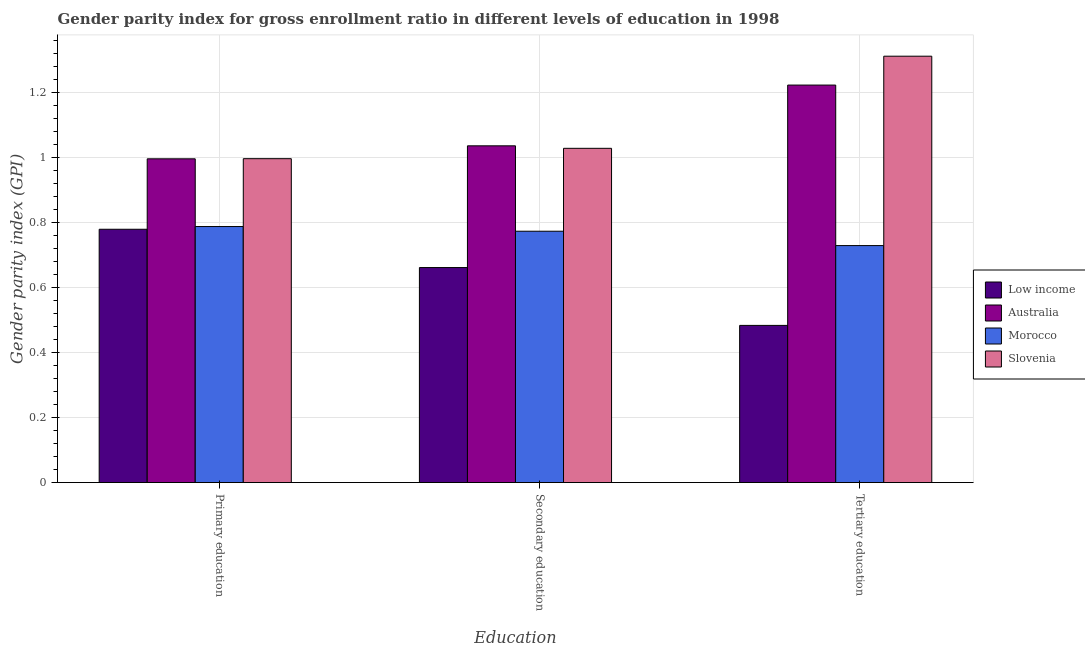How many groups of bars are there?
Make the answer very short. 3. Are the number of bars on each tick of the X-axis equal?
Make the answer very short. Yes. How many bars are there on the 1st tick from the right?
Give a very brief answer. 4. What is the gender parity index in secondary education in Slovenia?
Offer a terse response. 1.03. Across all countries, what is the maximum gender parity index in primary education?
Your answer should be compact. 1. Across all countries, what is the minimum gender parity index in tertiary education?
Your answer should be very brief. 0.48. In which country was the gender parity index in primary education maximum?
Offer a very short reply. Slovenia. In which country was the gender parity index in secondary education minimum?
Your answer should be very brief. Low income. What is the total gender parity index in primary education in the graph?
Offer a terse response. 3.56. What is the difference between the gender parity index in primary education in Australia and that in Morocco?
Provide a short and direct response. 0.21. What is the difference between the gender parity index in secondary education in Slovenia and the gender parity index in tertiary education in Low income?
Keep it short and to the point. 0.54. What is the average gender parity index in secondary education per country?
Make the answer very short. 0.87. What is the difference between the gender parity index in primary education and gender parity index in secondary education in Morocco?
Your answer should be compact. 0.01. What is the ratio of the gender parity index in secondary education in Australia to that in Slovenia?
Provide a succinct answer. 1.01. Is the difference between the gender parity index in tertiary education in Slovenia and Low income greater than the difference between the gender parity index in primary education in Slovenia and Low income?
Make the answer very short. Yes. What is the difference between the highest and the second highest gender parity index in tertiary education?
Offer a terse response. 0.09. What is the difference between the highest and the lowest gender parity index in tertiary education?
Offer a terse response. 0.83. In how many countries, is the gender parity index in primary education greater than the average gender parity index in primary education taken over all countries?
Keep it short and to the point. 2. Is the sum of the gender parity index in secondary education in Low income and Slovenia greater than the maximum gender parity index in tertiary education across all countries?
Give a very brief answer. Yes. What does the 4th bar from the left in Tertiary education represents?
Provide a succinct answer. Slovenia. What does the 1st bar from the right in Secondary education represents?
Make the answer very short. Slovenia. Is it the case that in every country, the sum of the gender parity index in primary education and gender parity index in secondary education is greater than the gender parity index in tertiary education?
Make the answer very short. Yes. How many bars are there?
Your response must be concise. 12. What is the difference between two consecutive major ticks on the Y-axis?
Provide a succinct answer. 0.2. Are the values on the major ticks of Y-axis written in scientific E-notation?
Offer a very short reply. No. Does the graph contain any zero values?
Make the answer very short. No. How are the legend labels stacked?
Ensure brevity in your answer.  Vertical. What is the title of the graph?
Provide a short and direct response. Gender parity index for gross enrollment ratio in different levels of education in 1998. What is the label or title of the X-axis?
Your answer should be compact. Education. What is the label or title of the Y-axis?
Provide a short and direct response. Gender parity index (GPI). What is the Gender parity index (GPI) in Low income in Primary education?
Provide a succinct answer. 0.78. What is the Gender parity index (GPI) in Australia in Primary education?
Offer a terse response. 1. What is the Gender parity index (GPI) in Morocco in Primary education?
Your answer should be very brief. 0.79. What is the Gender parity index (GPI) in Slovenia in Primary education?
Offer a terse response. 1. What is the Gender parity index (GPI) in Low income in Secondary education?
Offer a very short reply. 0.66. What is the Gender parity index (GPI) in Australia in Secondary education?
Ensure brevity in your answer.  1.04. What is the Gender parity index (GPI) in Morocco in Secondary education?
Provide a succinct answer. 0.77. What is the Gender parity index (GPI) of Slovenia in Secondary education?
Your answer should be compact. 1.03. What is the Gender parity index (GPI) in Low income in Tertiary education?
Make the answer very short. 0.48. What is the Gender parity index (GPI) in Australia in Tertiary education?
Ensure brevity in your answer.  1.22. What is the Gender parity index (GPI) of Morocco in Tertiary education?
Your answer should be compact. 0.73. What is the Gender parity index (GPI) of Slovenia in Tertiary education?
Provide a short and direct response. 1.31. Across all Education, what is the maximum Gender parity index (GPI) in Low income?
Offer a terse response. 0.78. Across all Education, what is the maximum Gender parity index (GPI) of Australia?
Give a very brief answer. 1.22. Across all Education, what is the maximum Gender parity index (GPI) in Morocco?
Ensure brevity in your answer.  0.79. Across all Education, what is the maximum Gender parity index (GPI) in Slovenia?
Offer a very short reply. 1.31. Across all Education, what is the minimum Gender parity index (GPI) in Low income?
Give a very brief answer. 0.48. Across all Education, what is the minimum Gender parity index (GPI) in Australia?
Your answer should be compact. 1. Across all Education, what is the minimum Gender parity index (GPI) in Morocco?
Make the answer very short. 0.73. Across all Education, what is the minimum Gender parity index (GPI) of Slovenia?
Offer a terse response. 1. What is the total Gender parity index (GPI) of Low income in the graph?
Provide a succinct answer. 1.92. What is the total Gender parity index (GPI) of Australia in the graph?
Give a very brief answer. 3.25. What is the total Gender parity index (GPI) in Morocco in the graph?
Offer a very short reply. 2.29. What is the total Gender parity index (GPI) of Slovenia in the graph?
Keep it short and to the point. 3.34. What is the difference between the Gender parity index (GPI) of Low income in Primary education and that in Secondary education?
Keep it short and to the point. 0.12. What is the difference between the Gender parity index (GPI) of Australia in Primary education and that in Secondary education?
Make the answer very short. -0.04. What is the difference between the Gender parity index (GPI) in Morocco in Primary education and that in Secondary education?
Provide a short and direct response. 0.01. What is the difference between the Gender parity index (GPI) in Slovenia in Primary education and that in Secondary education?
Offer a very short reply. -0.03. What is the difference between the Gender parity index (GPI) of Low income in Primary education and that in Tertiary education?
Offer a terse response. 0.3. What is the difference between the Gender parity index (GPI) of Australia in Primary education and that in Tertiary education?
Your answer should be compact. -0.23. What is the difference between the Gender parity index (GPI) of Morocco in Primary education and that in Tertiary education?
Your answer should be very brief. 0.06. What is the difference between the Gender parity index (GPI) in Slovenia in Primary education and that in Tertiary education?
Provide a succinct answer. -0.32. What is the difference between the Gender parity index (GPI) of Low income in Secondary education and that in Tertiary education?
Provide a succinct answer. 0.18. What is the difference between the Gender parity index (GPI) in Australia in Secondary education and that in Tertiary education?
Ensure brevity in your answer.  -0.19. What is the difference between the Gender parity index (GPI) in Morocco in Secondary education and that in Tertiary education?
Ensure brevity in your answer.  0.04. What is the difference between the Gender parity index (GPI) of Slovenia in Secondary education and that in Tertiary education?
Keep it short and to the point. -0.28. What is the difference between the Gender parity index (GPI) of Low income in Primary education and the Gender parity index (GPI) of Australia in Secondary education?
Offer a very short reply. -0.26. What is the difference between the Gender parity index (GPI) of Low income in Primary education and the Gender parity index (GPI) of Morocco in Secondary education?
Your answer should be very brief. 0.01. What is the difference between the Gender parity index (GPI) in Low income in Primary education and the Gender parity index (GPI) in Slovenia in Secondary education?
Your answer should be very brief. -0.25. What is the difference between the Gender parity index (GPI) in Australia in Primary education and the Gender parity index (GPI) in Morocco in Secondary education?
Ensure brevity in your answer.  0.22. What is the difference between the Gender parity index (GPI) of Australia in Primary education and the Gender parity index (GPI) of Slovenia in Secondary education?
Your response must be concise. -0.03. What is the difference between the Gender parity index (GPI) of Morocco in Primary education and the Gender parity index (GPI) of Slovenia in Secondary education?
Offer a very short reply. -0.24. What is the difference between the Gender parity index (GPI) in Low income in Primary education and the Gender parity index (GPI) in Australia in Tertiary education?
Your answer should be compact. -0.44. What is the difference between the Gender parity index (GPI) in Low income in Primary education and the Gender parity index (GPI) in Morocco in Tertiary education?
Make the answer very short. 0.05. What is the difference between the Gender parity index (GPI) in Low income in Primary education and the Gender parity index (GPI) in Slovenia in Tertiary education?
Offer a terse response. -0.53. What is the difference between the Gender parity index (GPI) in Australia in Primary education and the Gender parity index (GPI) in Morocco in Tertiary education?
Offer a terse response. 0.27. What is the difference between the Gender parity index (GPI) of Australia in Primary education and the Gender parity index (GPI) of Slovenia in Tertiary education?
Provide a short and direct response. -0.32. What is the difference between the Gender parity index (GPI) of Morocco in Primary education and the Gender parity index (GPI) of Slovenia in Tertiary education?
Provide a short and direct response. -0.52. What is the difference between the Gender parity index (GPI) in Low income in Secondary education and the Gender parity index (GPI) in Australia in Tertiary education?
Your response must be concise. -0.56. What is the difference between the Gender parity index (GPI) of Low income in Secondary education and the Gender parity index (GPI) of Morocco in Tertiary education?
Make the answer very short. -0.07. What is the difference between the Gender parity index (GPI) of Low income in Secondary education and the Gender parity index (GPI) of Slovenia in Tertiary education?
Keep it short and to the point. -0.65. What is the difference between the Gender parity index (GPI) of Australia in Secondary education and the Gender parity index (GPI) of Morocco in Tertiary education?
Offer a terse response. 0.31. What is the difference between the Gender parity index (GPI) in Australia in Secondary education and the Gender parity index (GPI) in Slovenia in Tertiary education?
Offer a terse response. -0.28. What is the difference between the Gender parity index (GPI) in Morocco in Secondary education and the Gender parity index (GPI) in Slovenia in Tertiary education?
Your answer should be very brief. -0.54. What is the average Gender parity index (GPI) in Low income per Education?
Offer a very short reply. 0.64. What is the average Gender parity index (GPI) of Australia per Education?
Your response must be concise. 1.08. What is the average Gender parity index (GPI) of Morocco per Education?
Give a very brief answer. 0.76. What is the average Gender parity index (GPI) of Slovenia per Education?
Ensure brevity in your answer.  1.11. What is the difference between the Gender parity index (GPI) in Low income and Gender parity index (GPI) in Australia in Primary education?
Give a very brief answer. -0.22. What is the difference between the Gender parity index (GPI) of Low income and Gender parity index (GPI) of Morocco in Primary education?
Your response must be concise. -0.01. What is the difference between the Gender parity index (GPI) of Low income and Gender parity index (GPI) of Slovenia in Primary education?
Your answer should be compact. -0.22. What is the difference between the Gender parity index (GPI) in Australia and Gender parity index (GPI) in Morocco in Primary education?
Provide a short and direct response. 0.21. What is the difference between the Gender parity index (GPI) of Australia and Gender parity index (GPI) of Slovenia in Primary education?
Ensure brevity in your answer.  -0. What is the difference between the Gender parity index (GPI) of Morocco and Gender parity index (GPI) of Slovenia in Primary education?
Keep it short and to the point. -0.21. What is the difference between the Gender parity index (GPI) in Low income and Gender parity index (GPI) in Australia in Secondary education?
Your response must be concise. -0.37. What is the difference between the Gender parity index (GPI) of Low income and Gender parity index (GPI) of Morocco in Secondary education?
Offer a terse response. -0.11. What is the difference between the Gender parity index (GPI) in Low income and Gender parity index (GPI) in Slovenia in Secondary education?
Make the answer very short. -0.37. What is the difference between the Gender parity index (GPI) of Australia and Gender parity index (GPI) of Morocco in Secondary education?
Give a very brief answer. 0.26. What is the difference between the Gender parity index (GPI) in Australia and Gender parity index (GPI) in Slovenia in Secondary education?
Your answer should be compact. 0.01. What is the difference between the Gender parity index (GPI) of Morocco and Gender parity index (GPI) of Slovenia in Secondary education?
Offer a very short reply. -0.26. What is the difference between the Gender parity index (GPI) in Low income and Gender parity index (GPI) in Australia in Tertiary education?
Provide a short and direct response. -0.74. What is the difference between the Gender parity index (GPI) of Low income and Gender parity index (GPI) of Morocco in Tertiary education?
Provide a succinct answer. -0.25. What is the difference between the Gender parity index (GPI) of Low income and Gender parity index (GPI) of Slovenia in Tertiary education?
Keep it short and to the point. -0.83. What is the difference between the Gender parity index (GPI) in Australia and Gender parity index (GPI) in Morocco in Tertiary education?
Provide a short and direct response. 0.49. What is the difference between the Gender parity index (GPI) of Australia and Gender parity index (GPI) of Slovenia in Tertiary education?
Keep it short and to the point. -0.09. What is the difference between the Gender parity index (GPI) of Morocco and Gender parity index (GPI) of Slovenia in Tertiary education?
Provide a short and direct response. -0.58. What is the ratio of the Gender parity index (GPI) in Low income in Primary education to that in Secondary education?
Your answer should be compact. 1.18. What is the ratio of the Gender parity index (GPI) of Australia in Primary education to that in Secondary education?
Give a very brief answer. 0.96. What is the ratio of the Gender parity index (GPI) in Morocco in Primary education to that in Secondary education?
Offer a very short reply. 1.02. What is the ratio of the Gender parity index (GPI) of Slovenia in Primary education to that in Secondary education?
Provide a succinct answer. 0.97. What is the ratio of the Gender parity index (GPI) of Low income in Primary education to that in Tertiary education?
Ensure brevity in your answer.  1.61. What is the ratio of the Gender parity index (GPI) in Australia in Primary education to that in Tertiary education?
Provide a succinct answer. 0.81. What is the ratio of the Gender parity index (GPI) of Morocco in Primary education to that in Tertiary education?
Make the answer very short. 1.08. What is the ratio of the Gender parity index (GPI) of Slovenia in Primary education to that in Tertiary education?
Keep it short and to the point. 0.76. What is the ratio of the Gender parity index (GPI) in Low income in Secondary education to that in Tertiary education?
Your response must be concise. 1.37. What is the ratio of the Gender parity index (GPI) in Australia in Secondary education to that in Tertiary education?
Offer a terse response. 0.85. What is the ratio of the Gender parity index (GPI) in Morocco in Secondary education to that in Tertiary education?
Keep it short and to the point. 1.06. What is the ratio of the Gender parity index (GPI) in Slovenia in Secondary education to that in Tertiary education?
Your answer should be compact. 0.78. What is the difference between the highest and the second highest Gender parity index (GPI) of Low income?
Make the answer very short. 0.12. What is the difference between the highest and the second highest Gender parity index (GPI) in Australia?
Your answer should be compact. 0.19. What is the difference between the highest and the second highest Gender parity index (GPI) in Morocco?
Keep it short and to the point. 0.01. What is the difference between the highest and the second highest Gender parity index (GPI) in Slovenia?
Your response must be concise. 0.28. What is the difference between the highest and the lowest Gender parity index (GPI) of Low income?
Offer a very short reply. 0.3. What is the difference between the highest and the lowest Gender parity index (GPI) of Australia?
Your response must be concise. 0.23. What is the difference between the highest and the lowest Gender parity index (GPI) of Morocco?
Make the answer very short. 0.06. What is the difference between the highest and the lowest Gender parity index (GPI) of Slovenia?
Ensure brevity in your answer.  0.32. 